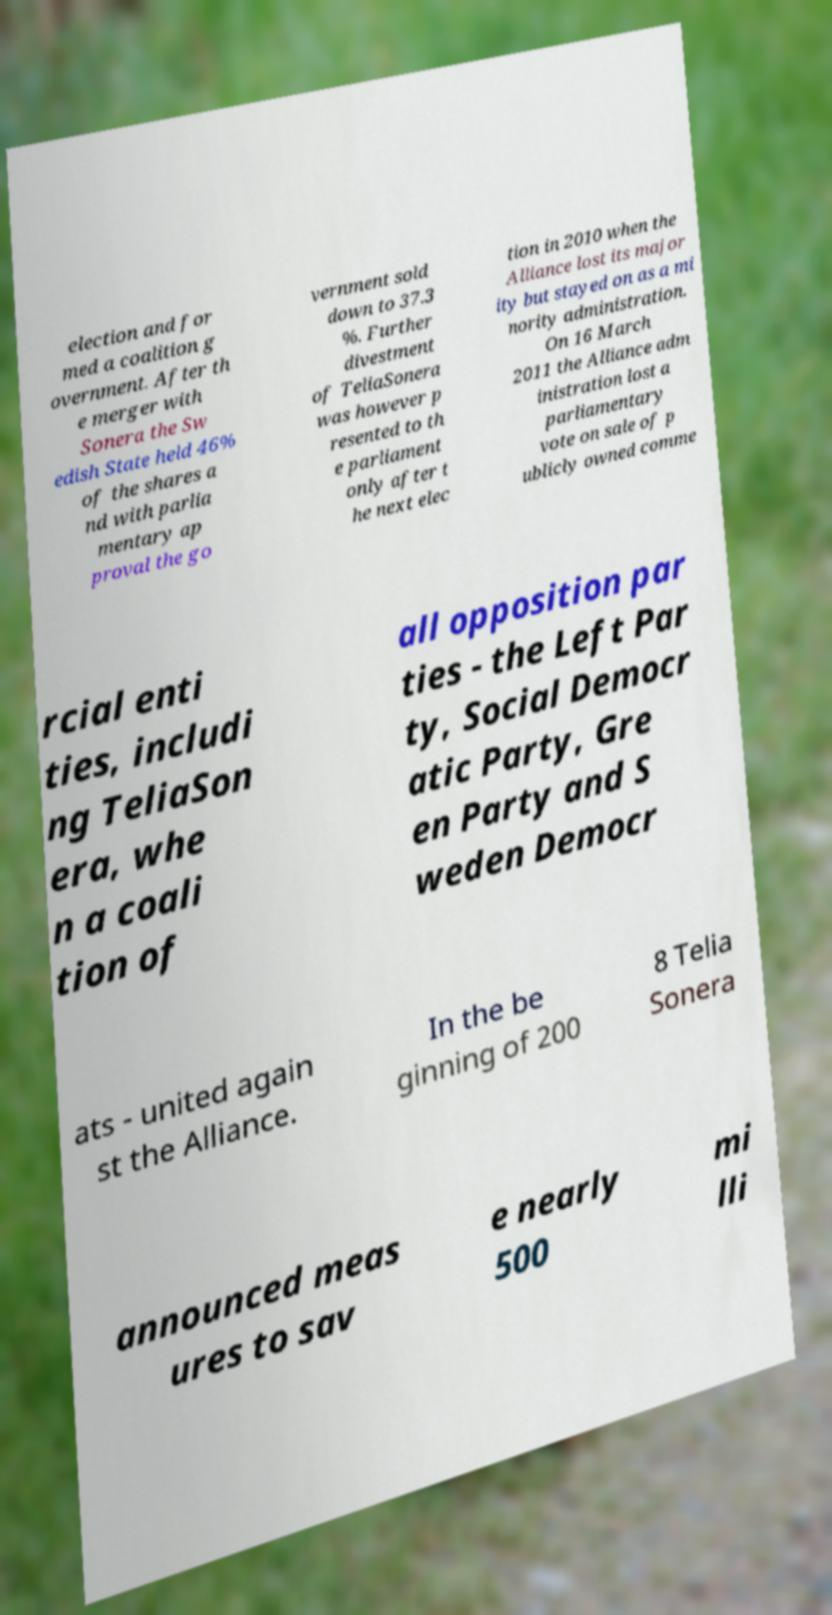What messages or text are displayed in this image? I need them in a readable, typed format. election and for med a coalition g overnment. After th e merger with Sonera the Sw edish State held 46% of the shares a nd with parlia mentary ap proval the go vernment sold down to 37.3 %. Further divestment of TeliaSonera was however p resented to th e parliament only after t he next elec tion in 2010 when the Alliance lost its major ity but stayed on as a mi nority administration. On 16 March 2011 the Alliance adm inistration lost a parliamentary vote on sale of p ublicly owned comme rcial enti ties, includi ng TeliaSon era, whe n a coali tion of all opposition par ties - the Left Par ty, Social Democr atic Party, Gre en Party and S weden Democr ats - united again st the Alliance. In the be ginning of 200 8 Telia Sonera announced meas ures to sav e nearly 500 mi lli 